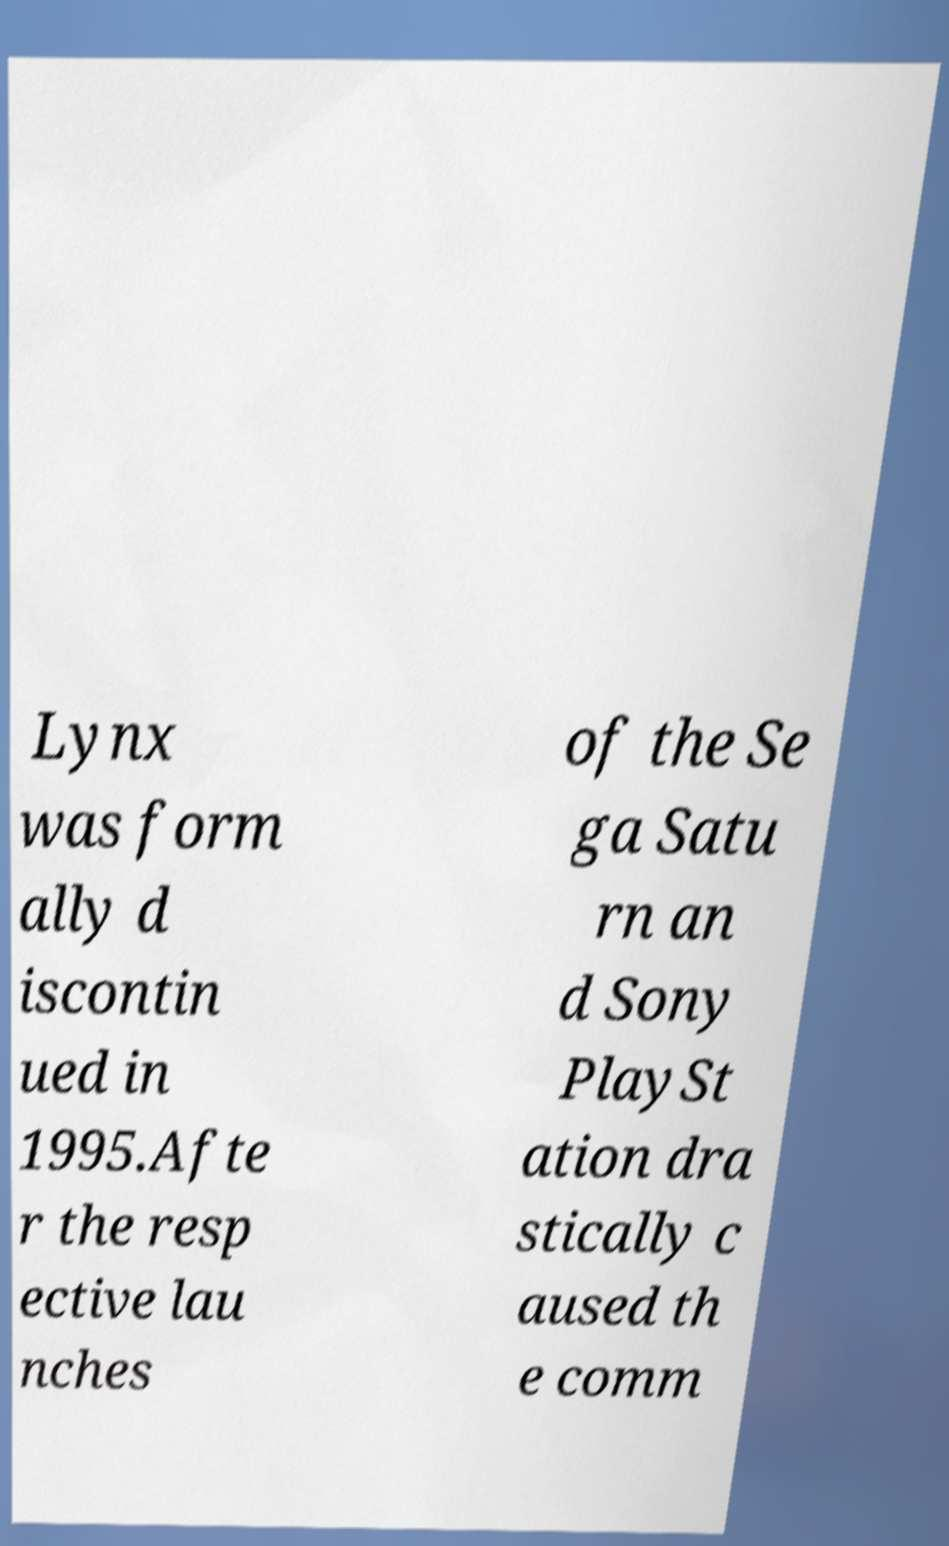For documentation purposes, I need the text within this image transcribed. Could you provide that? Lynx was form ally d iscontin ued in 1995.Afte r the resp ective lau nches of the Se ga Satu rn an d Sony PlaySt ation dra stically c aused th e comm 